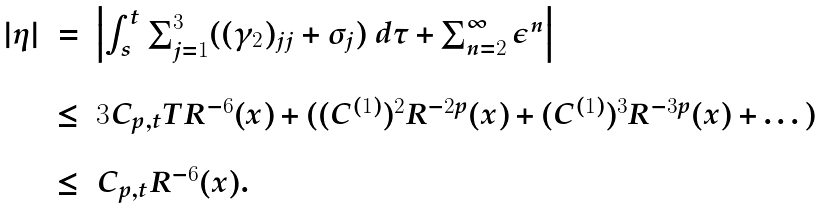<formula> <loc_0><loc_0><loc_500><loc_500>\begin{array} { r c l } | \eta | & = & \left | \int _ { s } ^ { t } \sum _ { j = 1 } ^ { 3 } ( ( \gamma _ { 2 } ) _ { j j } + \sigma _ { j } ) \ d \tau + \sum _ { n = 2 } ^ { \infty } \epsilon ^ { n } \right | \\ \\ & \leq & 3 C _ { p , t } T R ^ { - 6 } ( x ) + ( ( C ^ { ( 1 ) } ) ^ { 2 } R ^ { - 2 p } ( x ) + ( C ^ { ( 1 ) } ) ^ { 3 } R ^ { - 3 p } ( x ) + \dots ) \\ \\ & \leq & C _ { p , t } R ^ { - 6 } ( x ) . \end{array}</formula> 